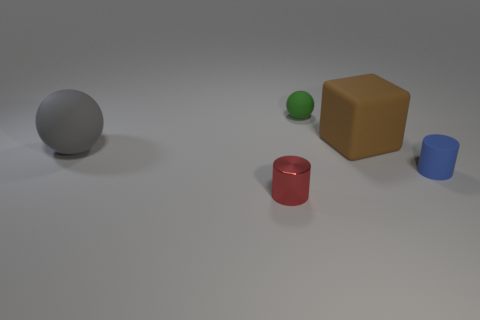There is a tiny object that is behind the large thing that is to the left of the big brown cube; what is its color? The small object positioned behind the larger item to the left of the sizeable brown cube exhibits a vibrant green color. 